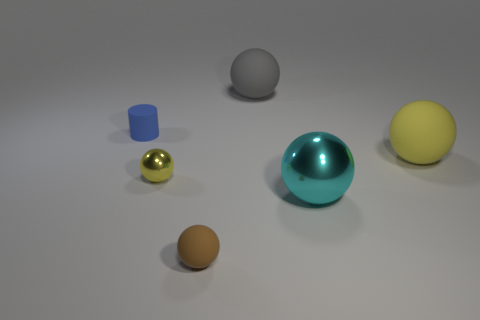Subtract 2 spheres. How many spheres are left? 3 Subtract all cyan spheres. How many spheres are left? 4 Subtract all blue balls. Subtract all gray cylinders. How many balls are left? 5 Add 2 large cyan spheres. How many objects exist? 8 Subtract all balls. How many objects are left? 1 Add 1 rubber balls. How many rubber balls are left? 4 Add 1 small yellow matte cubes. How many small yellow matte cubes exist? 1 Subtract 0 yellow cylinders. How many objects are left? 6 Subtract all brown rubber spheres. Subtract all small things. How many objects are left? 2 